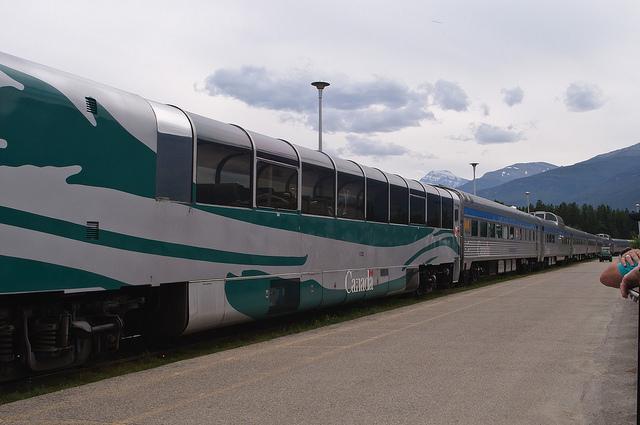Do you find any mountains in this picture?
Be succinct. Yes. Does the scene show people waiting for the bus?
Write a very short answer. No. What color is the train?
Be succinct. Green and white. What does the side of the bus say?
Answer briefly. Canada. 